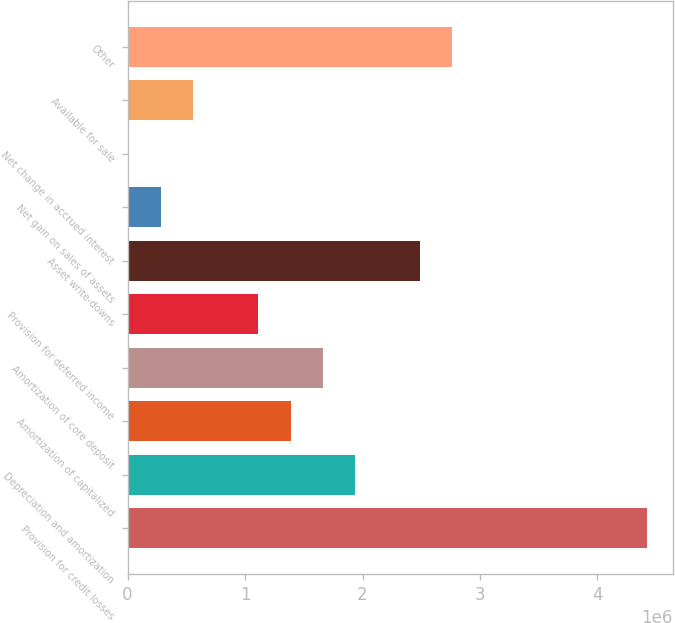<chart> <loc_0><loc_0><loc_500><loc_500><bar_chart><fcel>Provision for credit losses<fcel>Depreciation and amortization<fcel>Amortization of capitalized<fcel>Amortization of core deposit<fcel>Provision for deferred income<fcel>Asset write-downs<fcel>Net gain on sales of assets<fcel>Net change in accrued interest<fcel>Available for sale<fcel>Other<nl><fcel>4.4182e+06<fcel>1.93855e+06<fcel>1.38752e+06<fcel>1.66304e+06<fcel>1.11201e+06<fcel>2.48959e+06<fcel>285458<fcel>9942<fcel>560974<fcel>2.7651e+06<nl></chart> 